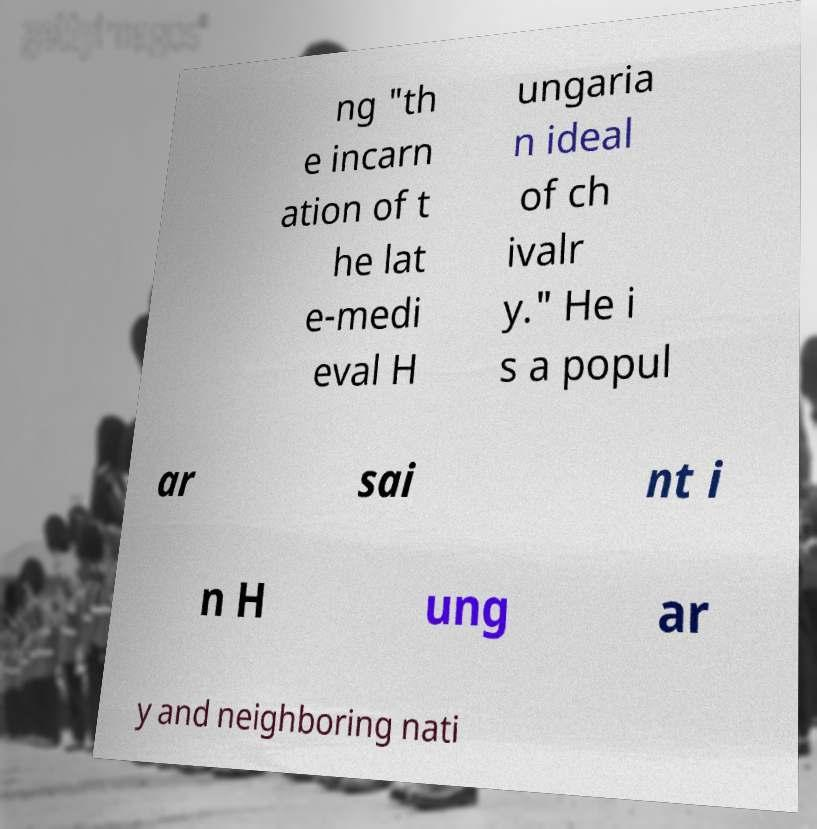Could you extract and type out the text from this image? ng "th e incarn ation of t he lat e-medi eval H ungaria n ideal of ch ivalr y." He i s a popul ar sai nt i n H ung ar y and neighboring nati 